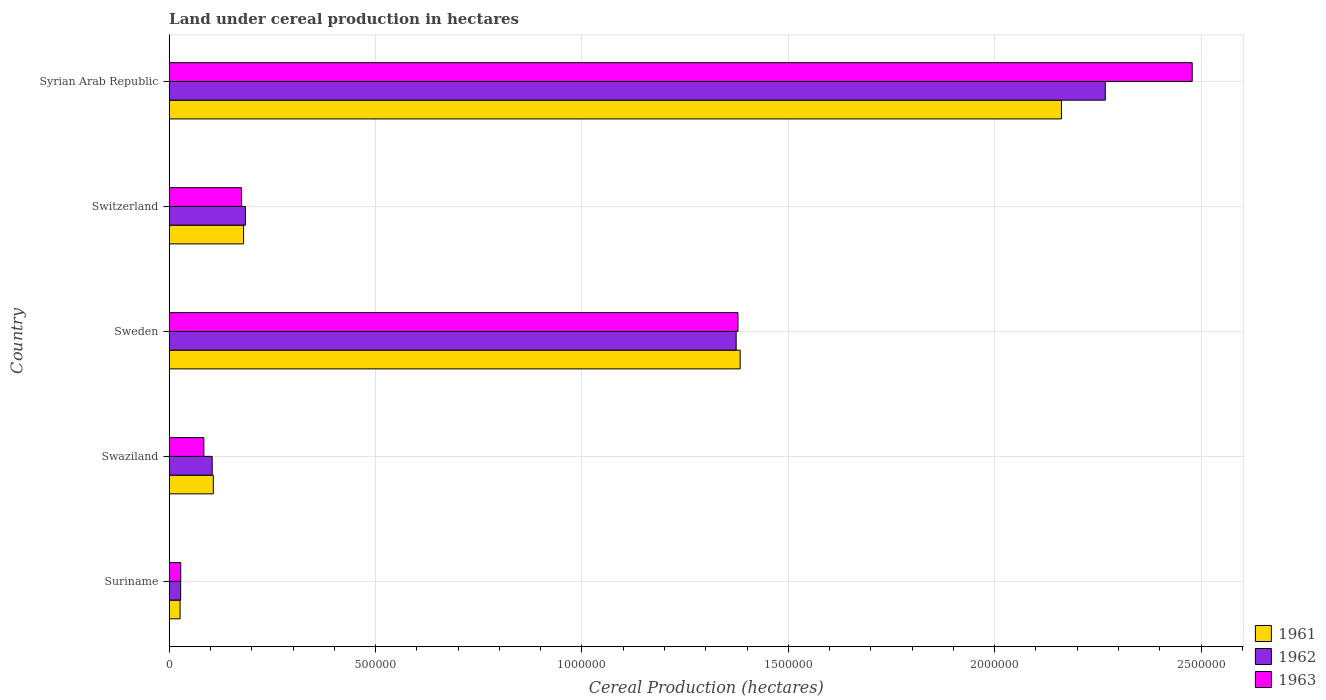Are the number of bars per tick equal to the number of legend labels?
Provide a succinct answer. Yes. How many bars are there on the 1st tick from the top?
Your answer should be very brief. 3. What is the label of the 2nd group of bars from the top?
Give a very brief answer. Switzerland. In how many cases, is the number of bars for a given country not equal to the number of legend labels?
Ensure brevity in your answer.  0. What is the land under cereal production in 1962 in Swaziland?
Make the answer very short. 1.04e+05. Across all countries, what is the maximum land under cereal production in 1962?
Keep it short and to the point. 2.27e+06. Across all countries, what is the minimum land under cereal production in 1963?
Ensure brevity in your answer.  2.79e+04. In which country was the land under cereal production in 1963 maximum?
Make the answer very short. Syrian Arab Republic. In which country was the land under cereal production in 1962 minimum?
Provide a short and direct response. Suriname. What is the total land under cereal production in 1961 in the graph?
Keep it short and to the point. 3.86e+06. What is the difference between the land under cereal production in 1961 in Suriname and that in Sweden?
Your answer should be compact. -1.36e+06. What is the difference between the land under cereal production in 1962 in Sweden and the land under cereal production in 1963 in Swaziland?
Keep it short and to the point. 1.29e+06. What is the average land under cereal production in 1963 per country?
Provide a short and direct response. 8.29e+05. What is the difference between the land under cereal production in 1963 and land under cereal production in 1961 in Swaziland?
Provide a short and direct response. -2.29e+04. What is the ratio of the land under cereal production in 1963 in Suriname to that in Syrian Arab Republic?
Your answer should be compact. 0.01. Is the land under cereal production in 1963 in Suriname less than that in Sweden?
Your answer should be compact. Yes. Is the difference between the land under cereal production in 1963 in Suriname and Syrian Arab Republic greater than the difference between the land under cereal production in 1961 in Suriname and Syrian Arab Republic?
Provide a succinct answer. No. What is the difference between the highest and the second highest land under cereal production in 1961?
Your answer should be compact. 7.78e+05. What is the difference between the highest and the lowest land under cereal production in 1963?
Offer a very short reply. 2.45e+06. Is the sum of the land under cereal production in 1963 in Swaziland and Syrian Arab Republic greater than the maximum land under cereal production in 1962 across all countries?
Your answer should be compact. Yes. How many bars are there?
Provide a short and direct response. 15. Are all the bars in the graph horizontal?
Provide a short and direct response. Yes. How many countries are there in the graph?
Provide a succinct answer. 5. Are the values on the major ticks of X-axis written in scientific E-notation?
Ensure brevity in your answer.  No. Does the graph contain any zero values?
Ensure brevity in your answer.  No. Does the graph contain grids?
Ensure brevity in your answer.  Yes. How many legend labels are there?
Give a very brief answer. 3. How are the legend labels stacked?
Keep it short and to the point. Vertical. What is the title of the graph?
Offer a terse response. Land under cereal production in hectares. Does "1974" appear as one of the legend labels in the graph?
Your response must be concise. No. What is the label or title of the X-axis?
Your answer should be very brief. Cereal Production (hectares). What is the label or title of the Y-axis?
Your answer should be compact. Country. What is the Cereal Production (hectares) of 1961 in Suriname?
Offer a very short reply. 2.63e+04. What is the Cereal Production (hectares) of 1962 in Suriname?
Give a very brief answer. 2.77e+04. What is the Cereal Production (hectares) in 1963 in Suriname?
Keep it short and to the point. 2.79e+04. What is the Cereal Production (hectares) of 1961 in Swaziland?
Offer a terse response. 1.07e+05. What is the Cereal Production (hectares) of 1962 in Swaziland?
Ensure brevity in your answer.  1.04e+05. What is the Cereal Production (hectares) in 1963 in Swaziland?
Make the answer very short. 8.40e+04. What is the Cereal Production (hectares) in 1961 in Sweden?
Your response must be concise. 1.38e+06. What is the Cereal Production (hectares) in 1962 in Sweden?
Keep it short and to the point. 1.37e+06. What is the Cereal Production (hectares) in 1963 in Sweden?
Offer a very short reply. 1.38e+06. What is the Cereal Production (hectares) of 1961 in Switzerland?
Give a very brief answer. 1.80e+05. What is the Cereal Production (hectares) in 1962 in Switzerland?
Offer a very short reply. 1.85e+05. What is the Cereal Production (hectares) of 1963 in Switzerland?
Make the answer very short. 1.75e+05. What is the Cereal Production (hectares) of 1961 in Syrian Arab Republic?
Give a very brief answer. 2.16e+06. What is the Cereal Production (hectares) of 1962 in Syrian Arab Republic?
Give a very brief answer. 2.27e+06. What is the Cereal Production (hectares) of 1963 in Syrian Arab Republic?
Offer a terse response. 2.48e+06. Across all countries, what is the maximum Cereal Production (hectares) of 1961?
Give a very brief answer. 2.16e+06. Across all countries, what is the maximum Cereal Production (hectares) of 1962?
Give a very brief answer. 2.27e+06. Across all countries, what is the maximum Cereal Production (hectares) of 1963?
Provide a succinct answer. 2.48e+06. Across all countries, what is the minimum Cereal Production (hectares) in 1961?
Offer a terse response. 2.63e+04. Across all countries, what is the minimum Cereal Production (hectares) of 1962?
Make the answer very short. 2.77e+04. Across all countries, what is the minimum Cereal Production (hectares) in 1963?
Ensure brevity in your answer.  2.79e+04. What is the total Cereal Production (hectares) in 1961 in the graph?
Make the answer very short. 3.86e+06. What is the total Cereal Production (hectares) of 1962 in the graph?
Offer a very short reply. 3.96e+06. What is the total Cereal Production (hectares) in 1963 in the graph?
Give a very brief answer. 4.14e+06. What is the difference between the Cereal Production (hectares) in 1961 in Suriname and that in Swaziland?
Provide a short and direct response. -8.06e+04. What is the difference between the Cereal Production (hectares) of 1962 in Suriname and that in Swaziland?
Keep it short and to the point. -7.64e+04. What is the difference between the Cereal Production (hectares) in 1963 in Suriname and that in Swaziland?
Offer a very short reply. -5.61e+04. What is the difference between the Cereal Production (hectares) in 1961 in Suriname and that in Sweden?
Offer a very short reply. -1.36e+06. What is the difference between the Cereal Production (hectares) in 1962 in Suriname and that in Sweden?
Your answer should be very brief. -1.35e+06. What is the difference between the Cereal Production (hectares) in 1963 in Suriname and that in Sweden?
Your answer should be very brief. -1.35e+06. What is the difference between the Cereal Production (hectares) in 1961 in Suriname and that in Switzerland?
Keep it short and to the point. -1.54e+05. What is the difference between the Cereal Production (hectares) of 1962 in Suriname and that in Switzerland?
Provide a succinct answer. -1.57e+05. What is the difference between the Cereal Production (hectares) of 1963 in Suriname and that in Switzerland?
Provide a short and direct response. -1.47e+05. What is the difference between the Cereal Production (hectares) of 1961 in Suriname and that in Syrian Arab Republic?
Offer a terse response. -2.14e+06. What is the difference between the Cereal Production (hectares) in 1962 in Suriname and that in Syrian Arab Republic?
Offer a very short reply. -2.24e+06. What is the difference between the Cereal Production (hectares) in 1963 in Suriname and that in Syrian Arab Republic?
Your response must be concise. -2.45e+06. What is the difference between the Cereal Production (hectares) of 1961 in Swaziland and that in Sweden?
Your answer should be compact. -1.28e+06. What is the difference between the Cereal Production (hectares) of 1962 in Swaziland and that in Sweden?
Offer a very short reply. -1.27e+06. What is the difference between the Cereal Production (hectares) in 1963 in Swaziland and that in Sweden?
Ensure brevity in your answer.  -1.29e+06. What is the difference between the Cereal Production (hectares) in 1961 in Swaziland and that in Switzerland?
Ensure brevity in your answer.  -7.34e+04. What is the difference between the Cereal Production (hectares) of 1962 in Swaziland and that in Switzerland?
Your answer should be compact. -8.05e+04. What is the difference between the Cereal Production (hectares) of 1963 in Swaziland and that in Switzerland?
Make the answer very short. -9.13e+04. What is the difference between the Cereal Production (hectares) of 1961 in Swaziland and that in Syrian Arab Republic?
Provide a succinct answer. -2.05e+06. What is the difference between the Cereal Production (hectares) of 1962 in Swaziland and that in Syrian Arab Republic?
Offer a terse response. -2.16e+06. What is the difference between the Cereal Production (hectares) of 1963 in Swaziland and that in Syrian Arab Republic?
Provide a short and direct response. -2.39e+06. What is the difference between the Cereal Production (hectares) of 1961 in Sweden and that in Switzerland?
Give a very brief answer. 1.20e+06. What is the difference between the Cereal Production (hectares) in 1962 in Sweden and that in Switzerland?
Keep it short and to the point. 1.19e+06. What is the difference between the Cereal Production (hectares) in 1963 in Sweden and that in Switzerland?
Ensure brevity in your answer.  1.20e+06. What is the difference between the Cereal Production (hectares) in 1961 in Sweden and that in Syrian Arab Republic?
Your response must be concise. -7.78e+05. What is the difference between the Cereal Production (hectares) of 1962 in Sweden and that in Syrian Arab Republic?
Ensure brevity in your answer.  -8.94e+05. What is the difference between the Cereal Production (hectares) of 1963 in Sweden and that in Syrian Arab Republic?
Provide a succinct answer. -1.10e+06. What is the difference between the Cereal Production (hectares) in 1961 in Switzerland and that in Syrian Arab Republic?
Your answer should be compact. -1.98e+06. What is the difference between the Cereal Production (hectares) of 1962 in Switzerland and that in Syrian Arab Republic?
Give a very brief answer. -2.08e+06. What is the difference between the Cereal Production (hectares) of 1963 in Switzerland and that in Syrian Arab Republic?
Give a very brief answer. -2.30e+06. What is the difference between the Cereal Production (hectares) in 1961 in Suriname and the Cereal Production (hectares) in 1962 in Swaziland?
Provide a short and direct response. -7.78e+04. What is the difference between the Cereal Production (hectares) of 1961 in Suriname and the Cereal Production (hectares) of 1963 in Swaziland?
Provide a short and direct response. -5.77e+04. What is the difference between the Cereal Production (hectares) of 1962 in Suriname and the Cereal Production (hectares) of 1963 in Swaziland?
Provide a succinct answer. -5.63e+04. What is the difference between the Cereal Production (hectares) of 1961 in Suriname and the Cereal Production (hectares) of 1962 in Sweden?
Provide a short and direct response. -1.35e+06. What is the difference between the Cereal Production (hectares) of 1961 in Suriname and the Cereal Production (hectares) of 1963 in Sweden?
Ensure brevity in your answer.  -1.35e+06. What is the difference between the Cereal Production (hectares) in 1962 in Suriname and the Cereal Production (hectares) in 1963 in Sweden?
Keep it short and to the point. -1.35e+06. What is the difference between the Cereal Production (hectares) of 1961 in Suriname and the Cereal Production (hectares) of 1962 in Switzerland?
Keep it short and to the point. -1.58e+05. What is the difference between the Cereal Production (hectares) of 1961 in Suriname and the Cereal Production (hectares) of 1963 in Switzerland?
Your answer should be very brief. -1.49e+05. What is the difference between the Cereal Production (hectares) in 1962 in Suriname and the Cereal Production (hectares) in 1963 in Switzerland?
Make the answer very short. -1.48e+05. What is the difference between the Cereal Production (hectares) in 1961 in Suriname and the Cereal Production (hectares) in 1962 in Syrian Arab Republic?
Give a very brief answer. -2.24e+06. What is the difference between the Cereal Production (hectares) in 1961 in Suriname and the Cereal Production (hectares) in 1963 in Syrian Arab Republic?
Keep it short and to the point. -2.45e+06. What is the difference between the Cereal Production (hectares) in 1962 in Suriname and the Cereal Production (hectares) in 1963 in Syrian Arab Republic?
Provide a short and direct response. -2.45e+06. What is the difference between the Cereal Production (hectares) in 1961 in Swaziland and the Cereal Production (hectares) in 1962 in Sweden?
Make the answer very short. -1.27e+06. What is the difference between the Cereal Production (hectares) in 1961 in Swaziland and the Cereal Production (hectares) in 1963 in Sweden?
Your answer should be compact. -1.27e+06. What is the difference between the Cereal Production (hectares) in 1962 in Swaziland and the Cereal Production (hectares) in 1963 in Sweden?
Ensure brevity in your answer.  -1.27e+06. What is the difference between the Cereal Production (hectares) in 1961 in Swaziland and the Cereal Production (hectares) in 1962 in Switzerland?
Give a very brief answer. -7.77e+04. What is the difference between the Cereal Production (hectares) of 1961 in Swaziland and the Cereal Production (hectares) of 1963 in Switzerland?
Ensure brevity in your answer.  -6.84e+04. What is the difference between the Cereal Production (hectares) of 1962 in Swaziland and the Cereal Production (hectares) of 1963 in Switzerland?
Your response must be concise. -7.12e+04. What is the difference between the Cereal Production (hectares) in 1961 in Swaziland and the Cereal Production (hectares) in 1962 in Syrian Arab Republic?
Your answer should be very brief. -2.16e+06. What is the difference between the Cereal Production (hectares) of 1961 in Swaziland and the Cereal Production (hectares) of 1963 in Syrian Arab Republic?
Offer a terse response. -2.37e+06. What is the difference between the Cereal Production (hectares) in 1962 in Swaziland and the Cereal Production (hectares) in 1963 in Syrian Arab Republic?
Give a very brief answer. -2.37e+06. What is the difference between the Cereal Production (hectares) of 1961 in Sweden and the Cereal Production (hectares) of 1962 in Switzerland?
Make the answer very short. 1.20e+06. What is the difference between the Cereal Production (hectares) of 1961 in Sweden and the Cereal Production (hectares) of 1963 in Switzerland?
Your response must be concise. 1.21e+06. What is the difference between the Cereal Production (hectares) in 1962 in Sweden and the Cereal Production (hectares) in 1963 in Switzerland?
Ensure brevity in your answer.  1.20e+06. What is the difference between the Cereal Production (hectares) of 1961 in Sweden and the Cereal Production (hectares) of 1962 in Syrian Arab Republic?
Offer a terse response. -8.85e+05. What is the difference between the Cereal Production (hectares) of 1961 in Sweden and the Cereal Production (hectares) of 1963 in Syrian Arab Republic?
Offer a very short reply. -1.10e+06. What is the difference between the Cereal Production (hectares) in 1962 in Sweden and the Cereal Production (hectares) in 1963 in Syrian Arab Republic?
Provide a succinct answer. -1.10e+06. What is the difference between the Cereal Production (hectares) of 1961 in Switzerland and the Cereal Production (hectares) of 1962 in Syrian Arab Republic?
Offer a very short reply. -2.09e+06. What is the difference between the Cereal Production (hectares) in 1961 in Switzerland and the Cereal Production (hectares) in 1963 in Syrian Arab Republic?
Keep it short and to the point. -2.30e+06. What is the difference between the Cereal Production (hectares) of 1962 in Switzerland and the Cereal Production (hectares) of 1963 in Syrian Arab Republic?
Ensure brevity in your answer.  -2.29e+06. What is the average Cereal Production (hectares) of 1961 per country?
Your response must be concise. 7.72e+05. What is the average Cereal Production (hectares) of 1962 per country?
Provide a succinct answer. 7.92e+05. What is the average Cereal Production (hectares) of 1963 per country?
Your answer should be very brief. 8.29e+05. What is the difference between the Cereal Production (hectares) in 1961 and Cereal Production (hectares) in 1962 in Suriname?
Give a very brief answer. -1390. What is the difference between the Cereal Production (hectares) in 1961 and Cereal Production (hectares) in 1963 in Suriname?
Offer a terse response. -1608. What is the difference between the Cereal Production (hectares) of 1962 and Cereal Production (hectares) of 1963 in Suriname?
Ensure brevity in your answer.  -218. What is the difference between the Cereal Production (hectares) of 1961 and Cereal Production (hectares) of 1962 in Swaziland?
Offer a very short reply. 2763. What is the difference between the Cereal Production (hectares) in 1961 and Cereal Production (hectares) in 1963 in Swaziland?
Ensure brevity in your answer.  2.29e+04. What is the difference between the Cereal Production (hectares) in 1962 and Cereal Production (hectares) in 1963 in Swaziland?
Offer a terse response. 2.01e+04. What is the difference between the Cereal Production (hectares) in 1961 and Cereal Production (hectares) in 1962 in Sweden?
Your answer should be very brief. 9669. What is the difference between the Cereal Production (hectares) of 1961 and Cereal Production (hectares) of 1963 in Sweden?
Ensure brevity in your answer.  5292. What is the difference between the Cereal Production (hectares) of 1962 and Cereal Production (hectares) of 1963 in Sweden?
Offer a terse response. -4377. What is the difference between the Cereal Production (hectares) in 1961 and Cereal Production (hectares) in 1962 in Switzerland?
Your answer should be compact. -4395. What is the difference between the Cereal Production (hectares) of 1961 and Cereal Production (hectares) of 1963 in Switzerland?
Provide a short and direct response. 4955. What is the difference between the Cereal Production (hectares) in 1962 and Cereal Production (hectares) in 1963 in Switzerland?
Offer a very short reply. 9350. What is the difference between the Cereal Production (hectares) in 1961 and Cereal Production (hectares) in 1962 in Syrian Arab Republic?
Offer a terse response. -1.06e+05. What is the difference between the Cereal Production (hectares) in 1961 and Cereal Production (hectares) in 1963 in Syrian Arab Republic?
Ensure brevity in your answer.  -3.17e+05. What is the difference between the Cereal Production (hectares) of 1962 and Cereal Production (hectares) of 1963 in Syrian Arab Republic?
Offer a terse response. -2.11e+05. What is the ratio of the Cereal Production (hectares) in 1961 in Suriname to that in Swaziland?
Your response must be concise. 0.25. What is the ratio of the Cereal Production (hectares) of 1962 in Suriname to that in Swaziland?
Provide a succinct answer. 0.27. What is the ratio of the Cereal Production (hectares) in 1963 in Suriname to that in Swaziland?
Provide a succinct answer. 0.33. What is the ratio of the Cereal Production (hectares) of 1961 in Suriname to that in Sweden?
Your answer should be compact. 0.02. What is the ratio of the Cereal Production (hectares) of 1962 in Suriname to that in Sweden?
Offer a terse response. 0.02. What is the ratio of the Cereal Production (hectares) in 1963 in Suriname to that in Sweden?
Ensure brevity in your answer.  0.02. What is the ratio of the Cereal Production (hectares) in 1961 in Suriname to that in Switzerland?
Provide a succinct answer. 0.15. What is the ratio of the Cereal Production (hectares) in 1962 in Suriname to that in Switzerland?
Ensure brevity in your answer.  0.15. What is the ratio of the Cereal Production (hectares) in 1963 in Suriname to that in Switzerland?
Offer a terse response. 0.16. What is the ratio of the Cereal Production (hectares) in 1961 in Suriname to that in Syrian Arab Republic?
Give a very brief answer. 0.01. What is the ratio of the Cereal Production (hectares) of 1962 in Suriname to that in Syrian Arab Republic?
Keep it short and to the point. 0.01. What is the ratio of the Cereal Production (hectares) in 1963 in Suriname to that in Syrian Arab Republic?
Provide a short and direct response. 0.01. What is the ratio of the Cereal Production (hectares) of 1961 in Swaziland to that in Sweden?
Your answer should be compact. 0.08. What is the ratio of the Cereal Production (hectares) in 1962 in Swaziland to that in Sweden?
Ensure brevity in your answer.  0.08. What is the ratio of the Cereal Production (hectares) of 1963 in Swaziland to that in Sweden?
Ensure brevity in your answer.  0.06. What is the ratio of the Cereal Production (hectares) of 1961 in Swaziland to that in Switzerland?
Your answer should be compact. 0.59. What is the ratio of the Cereal Production (hectares) of 1962 in Swaziland to that in Switzerland?
Your answer should be compact. 0.56. What is the ratio of the Cereal Production (hectares) of 1963 in Swaziland to that in Switzerland?
Keep it short and to the point. 0.48. What is the ratio of the Cereal Production (hectares) of 1961 in Swaziland to that in Syrian Arab Republic?
Your response must be concise. 0.05. What is the ratio of the Cereal Production (hectares) in 1962 in Swaziland to that in Syrian Arab Republic?
Offer a terse response. 0.05. What is the ratio of the Cereal Production (hectares) of 1963 in Swaziland to that in Syrian Arab Republic?
Your answer should be compact. 0.03. What is the ratio of the Cereal Production (hectares) in 1961 in Sweden to that in Switzerland?
Give a very brief answer. 7.67. What is the ratio of the Cereal Production (hectares) in 1962 in Sweden to that in Switzerland?
Give a very brief answer. 7.44. What is the ratio of the Cereal Production (hectares) of 1963 in Sweden to that in Switzerland?
Your answer should be very brief. 7.86. What is the ratio of the Cereal Production (hectares) of 1961 in Sweden to that in Syrian Arab Republic?
Provide a short and direct response. 0.64. What is the ratio of the Cereal Production (hectares) in 1962 in Sweden to that in Syrian Arab Republic?
Give a very brief answer. 0.61. What is the ratio of the Cereal Production (hectares) in 1963 in Sweden to that in Syrian Arab Republic?
Offer a very short reply. 0.56. What is the ratio of the Cereal Production (hectares) of 1961 in Switzerland to that in Syrian Arab Republic?
Make the answer very short. 0.08. What is the ratio of the Cereal Production (hectares) in 1962 in Switzerland to that in Syrian Arab Republic?
Your response must be concise. 0.08. What is the ratio of the Cereal Production (hectares) in 1963 in Switzerland to that in Syrian Arab Republic?
Offer a terse response. 0.07. What is the difference between the highest and the second highest Cereal Production (hectares) of 1961?
Your answer should be very brief. 7.78e+05. What is the difference between the highest and the second highest Cereal Production (hectares) of 1962?
Give a very brief answer. 8.94e+05. What is the difference between the highest and the second highest Cereal Production (hectares) of 1963?
Keep it short and to the point. 1.10e+06. What is the difference between the highest and the lowest Cereal Production (hectares) of 1961?
Offer a terse response. 2.14e+06. What is the difference between the highest and the lowest Cereal Production (hectares) of 1962?
Provide a succinct answer. 2.24e+06. What is the difference between the highest and the lowest Cereal Production (hectares) in 1963?
Offer a very short reply. 2.45e+06. 